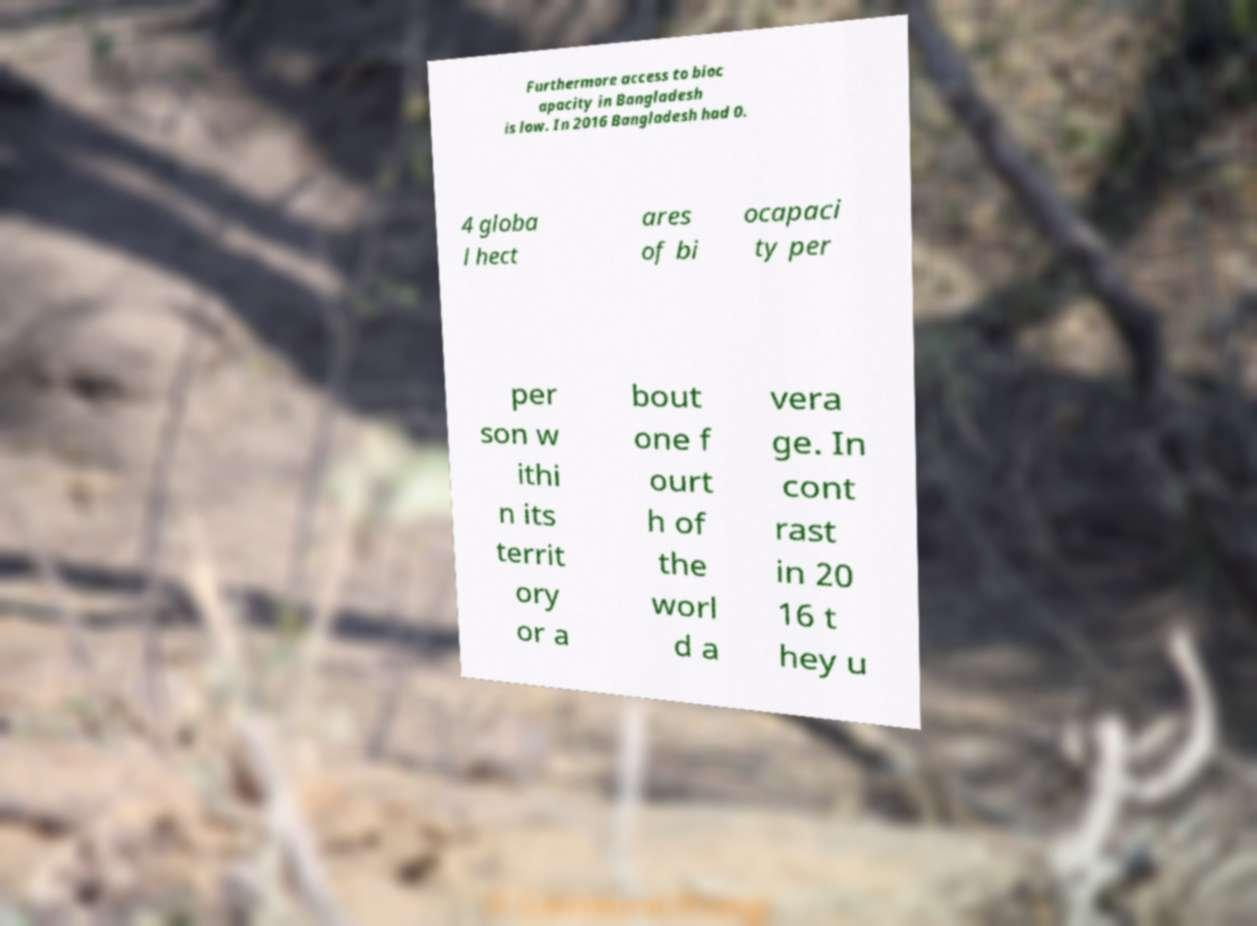Could you assist in decoding the text presented in this image and type it out clearly? Furthermore access to bioc apacity in Bangladesh is low. In 2016 Bangladesh had 0. 4 globa l hect ares of bi ocapaci ty per per son w ithi n its territ ory or a bout one f ourt h of the worl d a vera ge. In cont rast in 20 16 t hey u 